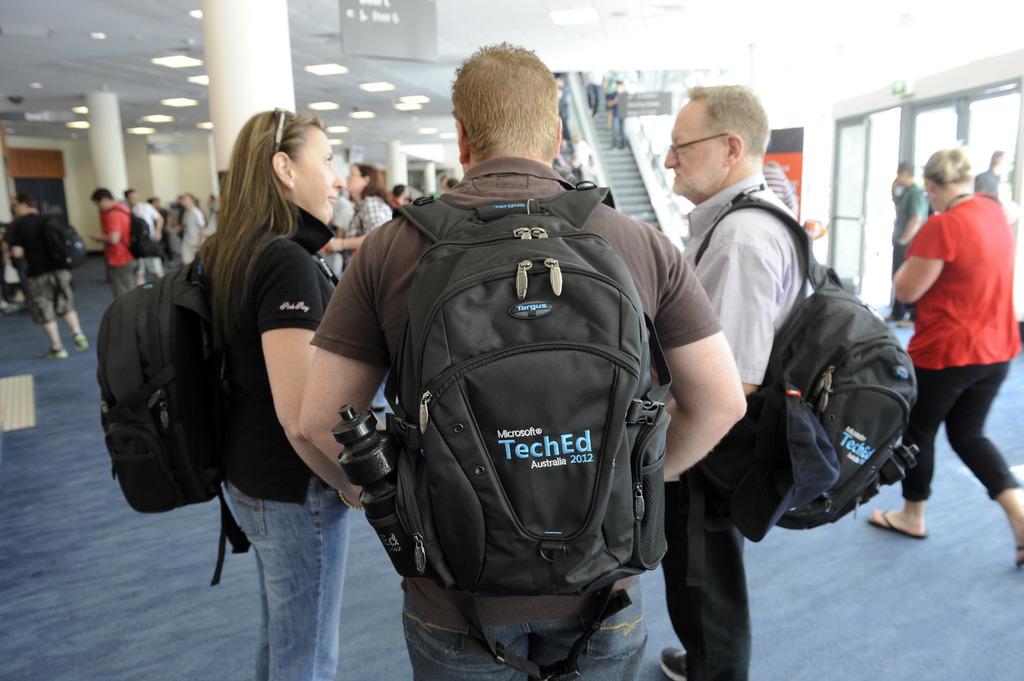What does the man's backpack say?
Your answer should be compact. Teched. 